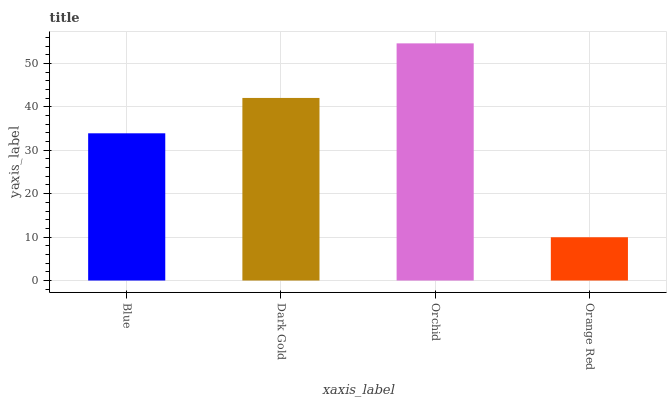Is Orchid the maximum?
Answer yes or no. Yes. Is Dark Gold the minimum?
Answer yes or no. No. Is Dark Gold the maximum?
Answer yes or no. No. Is Dark Gold greater than Blue?
Answer yes or no. Yes. Is Blue less than Dark Gold?
Answer yes or no. Yes. Is Blue greater than Dark Gold?
Answer yes or no. No. Is Dark Gold less than Blue?
Answer yes or no. No. Is Dark Gold the high median?
Answer yes or no. Yes. Is Blue the low median?
Answer yes or no. Yes. Is Orchid the high median?
Answer yes or no. No. Is Orchid the low median?
Answer yes or no. No. 